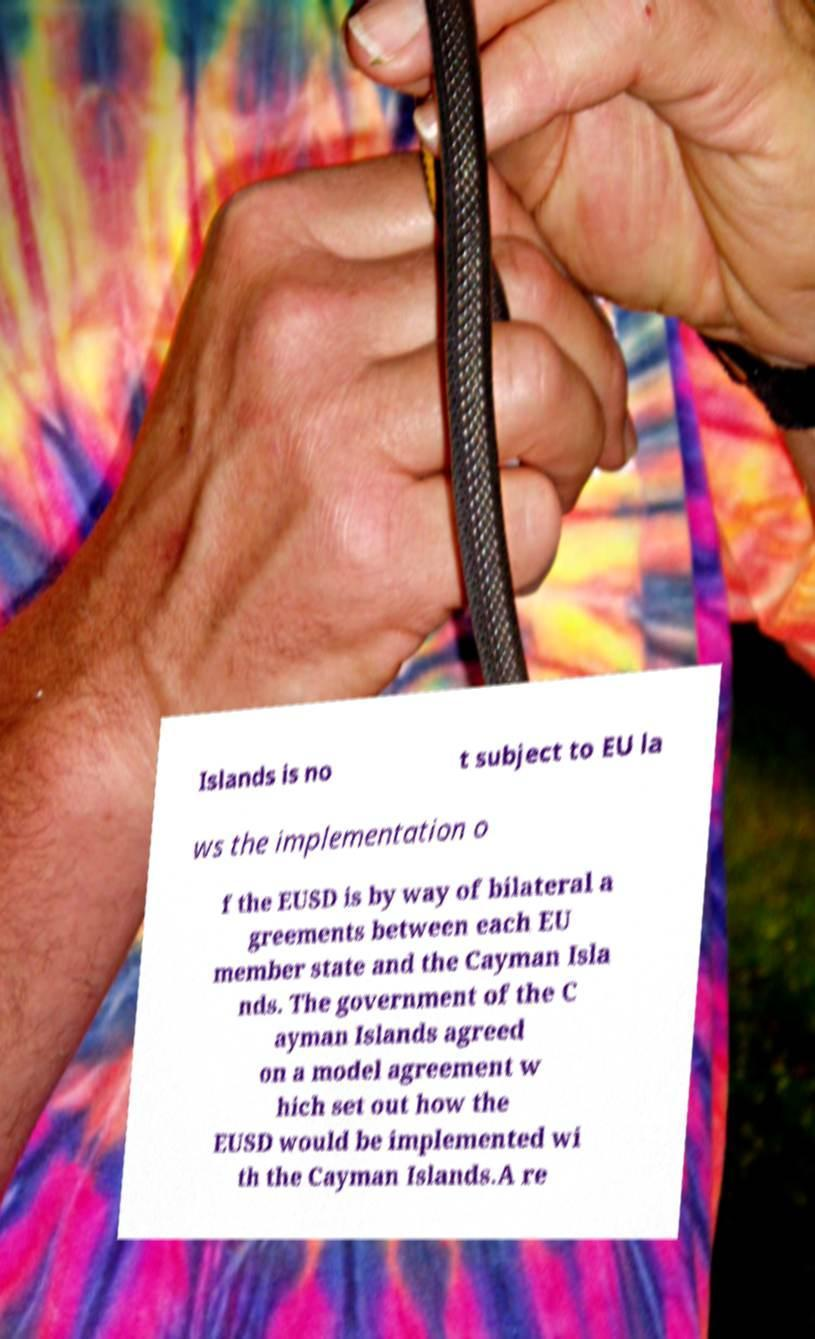Could you assist in decoding the text presented in this image and type it out clearly? Islands is no t subject to EU la ws the implementation o f the EUSD is by way of bilateral a greements between each EU member state and the Cayman Isla nds. The government of the C ayman Islands agreed on a model agreement w hich set out how the EUSD would be implemented wi th the Cayman Islands.A re 